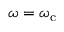Convert formula to latex. <formula><loc_0><loc_0><loc_500><loc_500>\omega = \omega _ { c }</formula> 